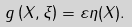Convert formula to latex. <formula><loc_0><loc_0><loc_500><loc_500>g \left ( X , \xi \right ) = \varepsilon \eta ( X ) .</formula> 